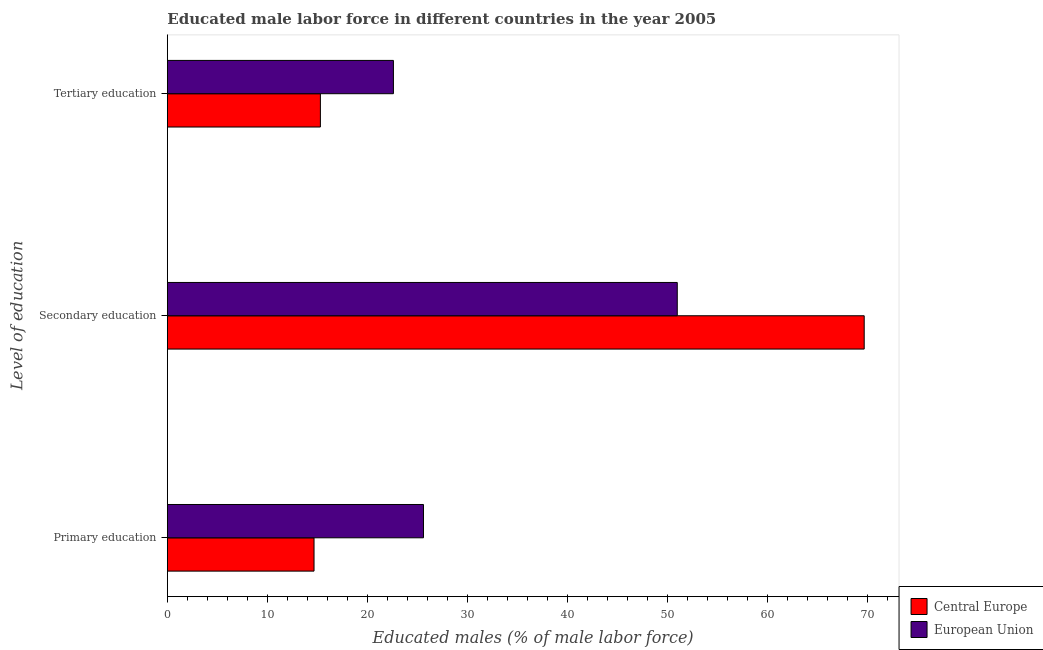How many bars are there on the 3rd tick from the bottom?
Offer a terse response. 2. What is the label of the 3rd group of bars from the top?
Your answer should be very brief. Primary education. What is the percentage of male labor force who received primary education in Central Europe?
Offer a terse response. 14.67. Across all countries, what is the maximum percentage of male labor force who received tertiary education?
Provide a short and direct response. 22.62. Across all countries, what is the minimum percentage of male labor force who received primary education?
Provide a succinct answer. 14.67. In which country was the percentage of male labor force who received tertiary education minimum?
Offer a very short reply. Central Europe. What is the total percentage of male labor force who received secondary education in the graph?
Keep it short and to the point. 120.73. What is the difference between the percentage of male labor force who received tertiary education in Central Europe and that in European Union?
Ensure brevity in your answer.  -7.31. What is the difference between the percentage of male labor force who received secondary education in Central Europe and the percentage of male labor force who received tertiary education in European Union?
Provide a succinct answer. 47.1. What is the average percentage of male labor force who received secondary education per country?
Offer a terse response. 60.37. What is the difference between the percentage of male labor force who received primary education and percentage of male labor force who received tertiary education in European Union?
Your answer should be compact. 3.01. What is the ratio of the percentage of male labor force who received primary education in European Union to that in Central Europe?
Keep it short and to the point. 1.75. What is the difference between the highest and the second highest percentage of male labor force who received tertiary education?
Offer a very short reply. 7.31. What is the difference between the highest and the lowest percentage of male labor force who received secondary education?
Offer a very short reply. 18.7. What does the 1st bar from the top in Primary education represents?
Make the answer very short. European Union. How many countries are there in the graph?
Ensure brevity in your answer.  2. What is the difference between two consecutive major ticks on the X-axis?
Your answer should be compact. 10. Are the values on the major ticks of X-axis written in scientific E-notation?
Your answer should be very brief. No. How many legend labels are there?
Your answer should be compact. 2. How are the legend labels stacked?
Your answer should be compact. Vertical. What is the title of the graph?
Offer a very short reply. Educated male labor force in different countries in the year 2005. What is the label or title of the X-axis?
Your answer should be compact. Educated males (% of male labor force). What is the label or title of the Y-axis?
Offer a terse response. Level of education. What is the Educated males (% of male labor force) in Central Europe in Primary education?
Keep it short and to the point. 14.67. What is the Educated males (% of male labor force) of European Union in Primary education?
Make the answer very short. 25.62. What is the Educated males (% of male labor force) of Central Europe in Secondary education?
Your answer should be very brief. 69.72. What is the Educated males (% of male labor force) of European Union in Secondary education?
Ensure brevity in your answer.  51.01. What is the Educated males (% of male labor force) in Central Europe in Tertiary education?
Offer a very short reply. 15.31. What is the Educated males (% of male labor force) of European Union in Tertiary education?
Your answer should be compact. 22.62. Across all Level of education, what is the maximum Educated males (% of male labor force) of Central Europe?
Ensure brevity in your answer.  69.72. Across all Level of education, what is the maximum Educated males (% of male labor force) in European Union?
Make the answer very short. 51.01. Across all Level of education, what is the minimum Educated males (% of male labor force) in Central Europe?
Offer a very short reply. 14.67. Across all Level of education, what is the minimum Educated males (% of male labor force) of European Union?
Your answer should be very brief. 22.62. What is the total Educated males (% of male labor force) of Central Europe in the graph?
Your response must be concise. 99.7. What is the total Educated males (% of male labor force) of European Union in the graph?
Your answer should be very brief. 99.25. What is the difference between the Educated males (% of male labor force) in Central Europe in Primary education and that in Secondary education?
Make the answer very short. -55.04. What is the difference between the Educated males (% of male labor force) of European Union in Primary education and that in Secondary education?
Make the answer very short. -25.39. What is the difference between the Educated males (% of male labor force) in Central Europe in Primary education and that in Tertiary education?
Your response must be concise. -0.64. What is the difference between the Educated males (% of male labor force) of European Union in Primary education and that in Tertiary education?
Provide a succinct answer. 3.01. What is the difference between the Educated males (% of male labor force) in Central Europe in Secondary education and that in Tertiary education?
Provide a short and direct response. 54.41. What is the difference between the Educated males (% of male labor force) of European Union in Secondary education and that in Tertiary education?
Provide a short and direct response. 28.4. What is the difference between the Educated males (% of male labor force) in Central Europe in Primary education and the Educated males (% of male labor force) in European Union in Secondary education?
Give a very brief answer. -36.34. What is the difference between the Educated males (% of male labor force) in Central Europe in Primary education and the Educated males (% of male labor force) in European Union in Tertiary education?
Your answer should be very brief. -7.94. What is the difference between the Educated males (% of male labor force) of Central Europe in Secondary education and the Educated males (% of male labor force) of European Union in Tertiary education?
Ensure brevity in your answer.  47.1. What is the average Educated males (% of male labor force) of Central Europe per Level of education?
Your response must be concise. 33.23. What is the average Educated males (% of male labor force) in European Union per Level of education?
Provide a short and direct response. 33.08. What is the difference between the Educated males (% of male labor force) in Central Europe and Educated males (% of male labor force) in European Union in Primary education?
Make the answer very short. -10.95. What is the difference between the Educated males (% of male labor force) of Central Europe and Educated males (% of male labor force) of European Union in Secondary education?
Make the answer very short. 18.7. What is the difference between the Educated males (% of male labor force) of Central Europe and Educated males (% of male labor force) of European Union in Tertiary education?
Your response must be concise. -7.31. What is the ratio of the Educated males (% of male labor force) of Central Europe in Primary education to that in Secondary education?
Provide a succinct answer. 0.21. What is the ratio of the Educated males (% of male labor force) of European Union in Primary education to that in Secondary education?
Make the answer very short. 0.5. What is the ratio of the Educated males (% of male labor force) of Central Europe in Primary education to that in Tertiary education?
Provide a succinct answer. 0.96. What is the ratio of the Educated males (% of male labor force) of European Union in Primary education to that in Tertiary education?
Ensure brevity in your answer.  1.13. What is the ratio of the Educated males (% of male labor force) in Central Europe in Secondary education to that in Tertiary education?
Your response must be concise. 4.55. What is the ratio of the Educated males (% of male labor force) in European Union in Secondary education to that in Tertiary education?
Your answer should be compact. 2.26. What is the difference between the highest and the second highest Educated males (% of male labor force) of Central Europe?
Provide a short and direct response. 54.41. What is the difference between the highest and the second highest Educated males (% of male labor force) in European Union?
Your answer should be compact. 25.39. What is the difference between the highest and the lowest Educated males (% of male labor force) of Central Europe?
Ensure brevity in your answer.  55.04. What is the difference between the highest and the lowest Educated males (% of male labor force) in European Union?
Your answer should be compact. 28.4. 